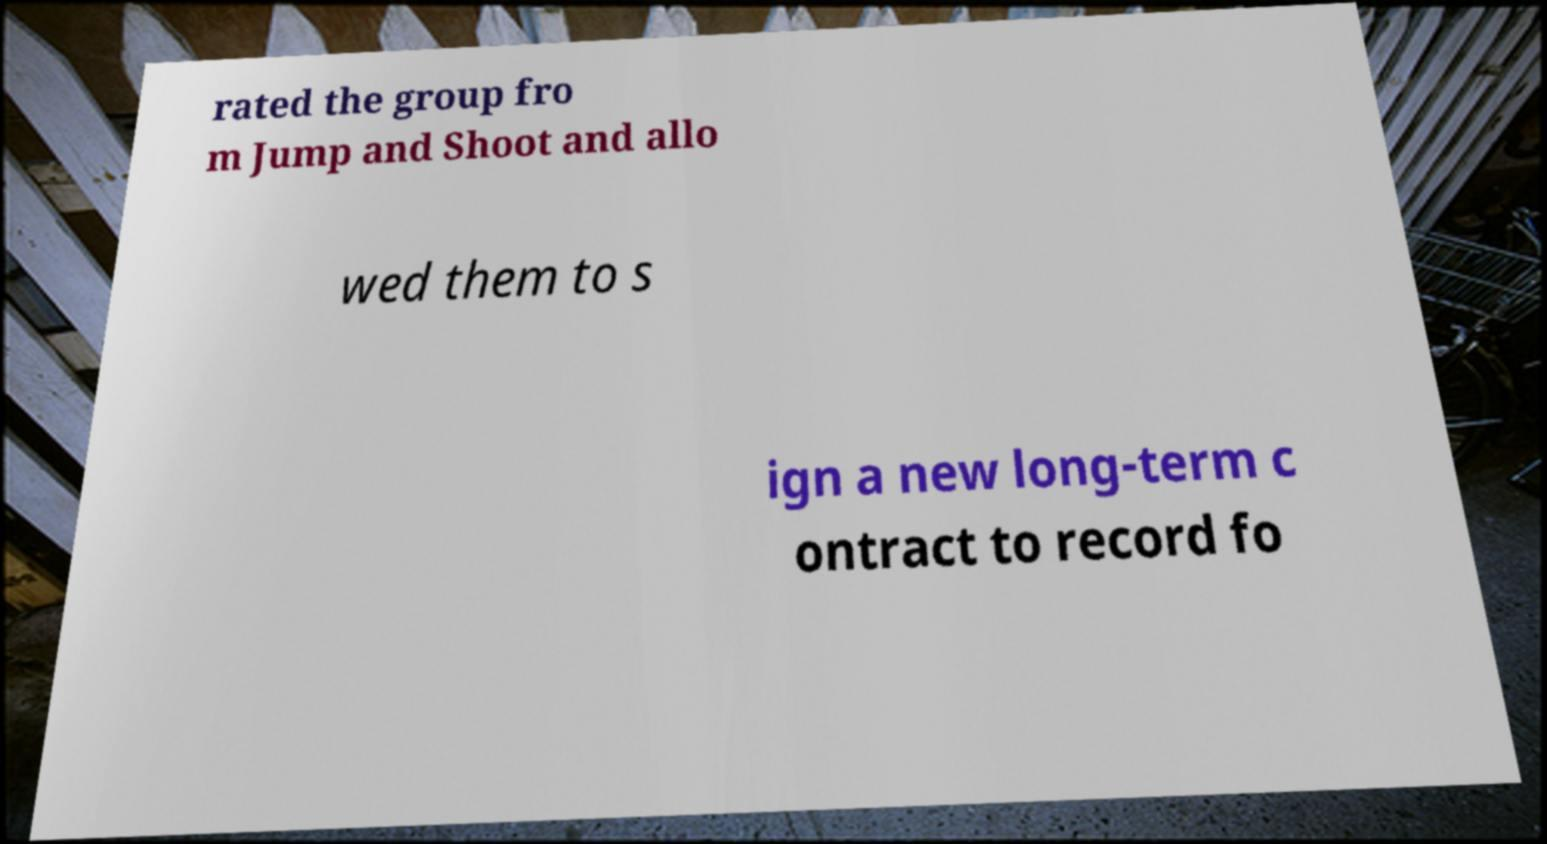Can you accurately transcribe the text from the provided image for me? rated the group fro m Jump and Shoot and allo wed them to s ign a new long-term c ontract to record fo 